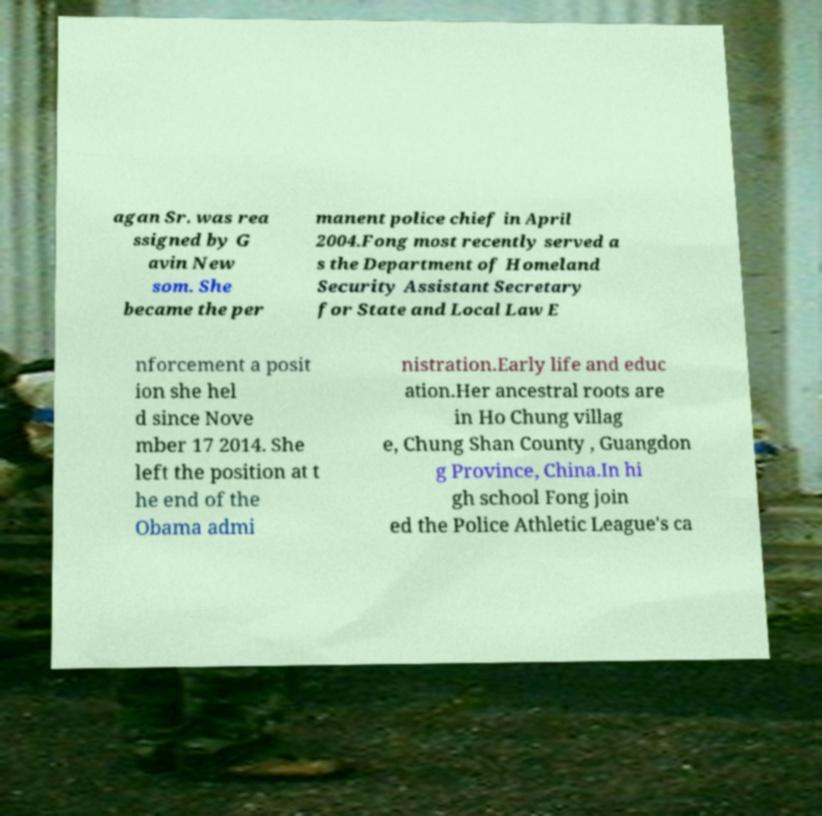Can you read and provide the text displayed in the image?This photo seems to have some interesting text. Can you extract and type it out for me? agan Sr. was rea ssigned by G avin New som. She became the per manent police chief in April 2004.Fong most recently served a s the Department of Homeland Security Assistant Secretary for State and Local Law E nforcement a posit ion she hel d since Nove mber 17 2014. She left the position at t he end of the Obama admi nistration.Early life and educ ation.Her ancestral roots are in Ho Chung villag e, Chung Shan County , Guangdon g Province, China.In hi gh school Fong join ed the Police Athletic League's ca 